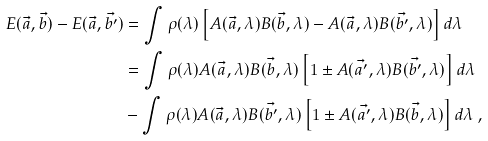<formula> <loc_0><loc_0><loc_500><loc_500>E ( \vec { a } , \vec { b } ) - E ( \vec { a } , \vec { b ^ { \prime } } ) & = \int { \rho ( \lambda ) \left [ A ( \vec { a } , \lambda ) B ( \vec { b } , \lambda ) - A ( \vec { a } , \lambda ) B ( \vec { b ^ { \prime } } , \lambda ) \right ] d \lambda } \\ & = \int { \rho ( \lambda ) A ( \vec { a } , \lambda ) B ( \vec { b } , \lambda ) \left [ 1 \pm A ( \vec { a ^ { \prime } } , \lambda ) B ( \vec { b ^ { \prime } } , \lambda ) \right ] d \lambda } \\ & - \int { \rho ( \lambda ) A ( \vec { a } , \lambda ) B ( \vec { b ^ { \prime } } , \lambda ) \left [ 1 \pm A ( \vec { a ^ { \prime } } , \lambda ) B ( \vec { b } , \lambda ) \right ] d \lambda } \ ,</formula> 